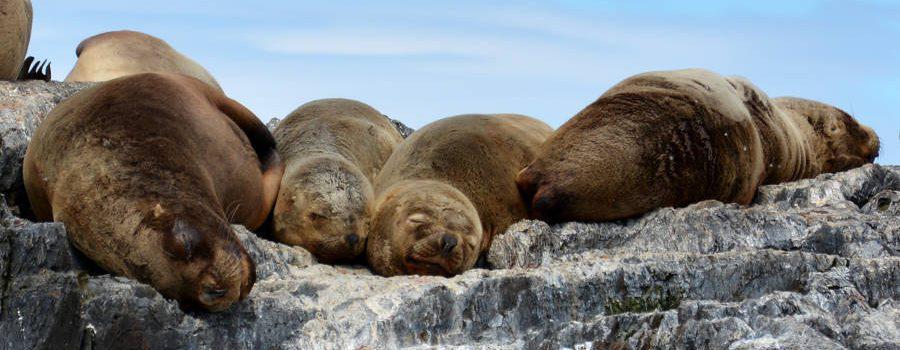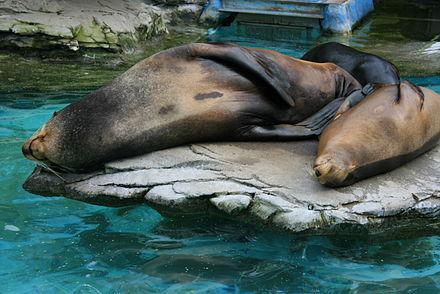The first image is the image on the left, the second image is the image on the right. For the images shown, is this caption "Left and right images show seals basking on rocks out of the water and include seals with their heads pointed toward the camera." true? Answer yes or no. Yes. The first image is the image on the left, the second image is the image on the right. Given the left and right images, does the statement "A single seal is sunning on a rock in the image on the left." hold true? Answer yes or no. No. 